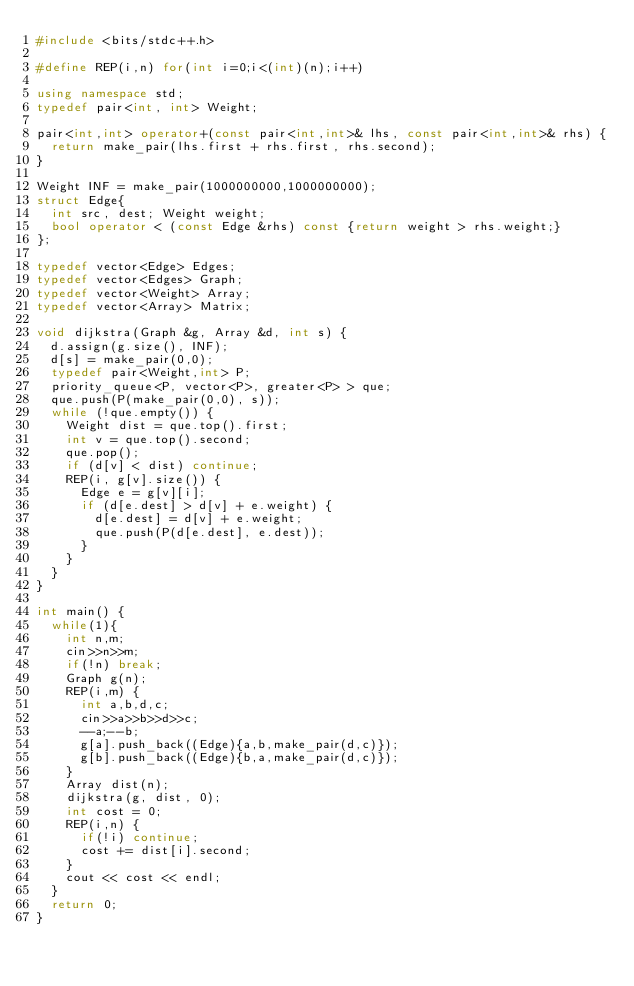Convert code to text. <code><loc_0><loc_0><loc_500><loc_500><_C++_>#include <bits/stdc++.h>

#define REP(i,n) for(int i=0;i<(int)(n);i++)

using namespace std;
typedef pair<int, int> Weight;

pair<int,int> operator+(const pair<int,int>& lhs, const pair<int,int>& rhs) {
  return make_pair(lhs.first + rhs.first, rhs.second);
}

Weight INF = make_pair(1000000000,1000000000);
struct Edge{
  int src, dest; Weight weight;
  bool operator < (const Edge &rhs) const {return weight > rhs.weight;}
};

typedef vector<Edge> Edges;
typedef vector<Edges> Graph;
typedef vector<Weight> Array;
typedef vector<Array> Matrix;

void dijkstra(Graph &g, Array &d, int s) {
  d.assign(g.size(), INF);
  d[s] = make_pair(0,0);
  typedef pair<Weight,int> P;
  priority_queue<P, vector<P>, greater<P> > que;
  que.push(P(make_pair(0,0), s));
  while (!que.empty()) {
    Weight dist = que.top().first;
    int v = que.top().second;
    que.pop();
    if (d[v] < dist) continue;
    REP(i, g[v].size()) {
      Edge e = g[v][i];
      if (d[e.dest] > d[v] + e.weight) {
        d[e.dest] = d[v] + e.weight;
        que.push(P(d[e.dest], e.dest));
      }
    }
  }
}

int main() {
  while(1){
    int n,m;
    cin>>n>>m;
    if(!n) break;
    Graph g(n);
    REP(i,m) {
      int a,b,d,c;
      cin>>a>>b>>d>>c;
      --a;--b;
      g[a].push_back((Edge){a,b,make_pair(d,c)});
      g[b].push_back((Edge){b,a,make_pair(d,c)});
    }
    Array dist(n);
    dijkstra(g, dist, 0);
    int cost = 0;
    REP(i,n) {
      if(!i) continue;
      cost += dist[i].second;
    }
    cout << cost << endl;
  }
  return 0;
}</code> 